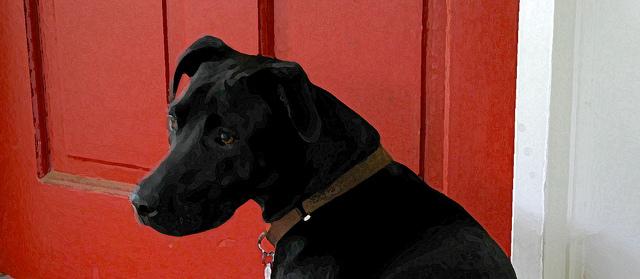What color is the door?
Give a very brief answer. Red. What animal is shown in the picture?
Give a very brief answer. Dog. What color is the dog?
Give a very brief answer. Black. 